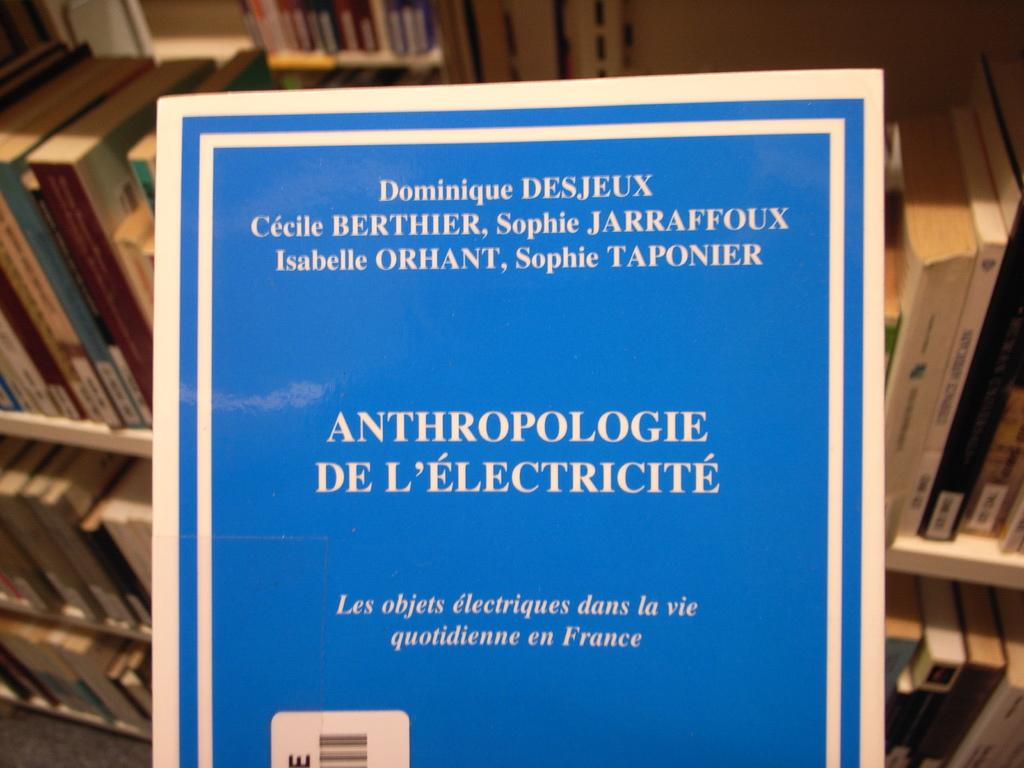<image>
Describe the image concisely. A blue paper with foreign print that says ANTHROPOLOGIE DE L'ELECTRICITE. 